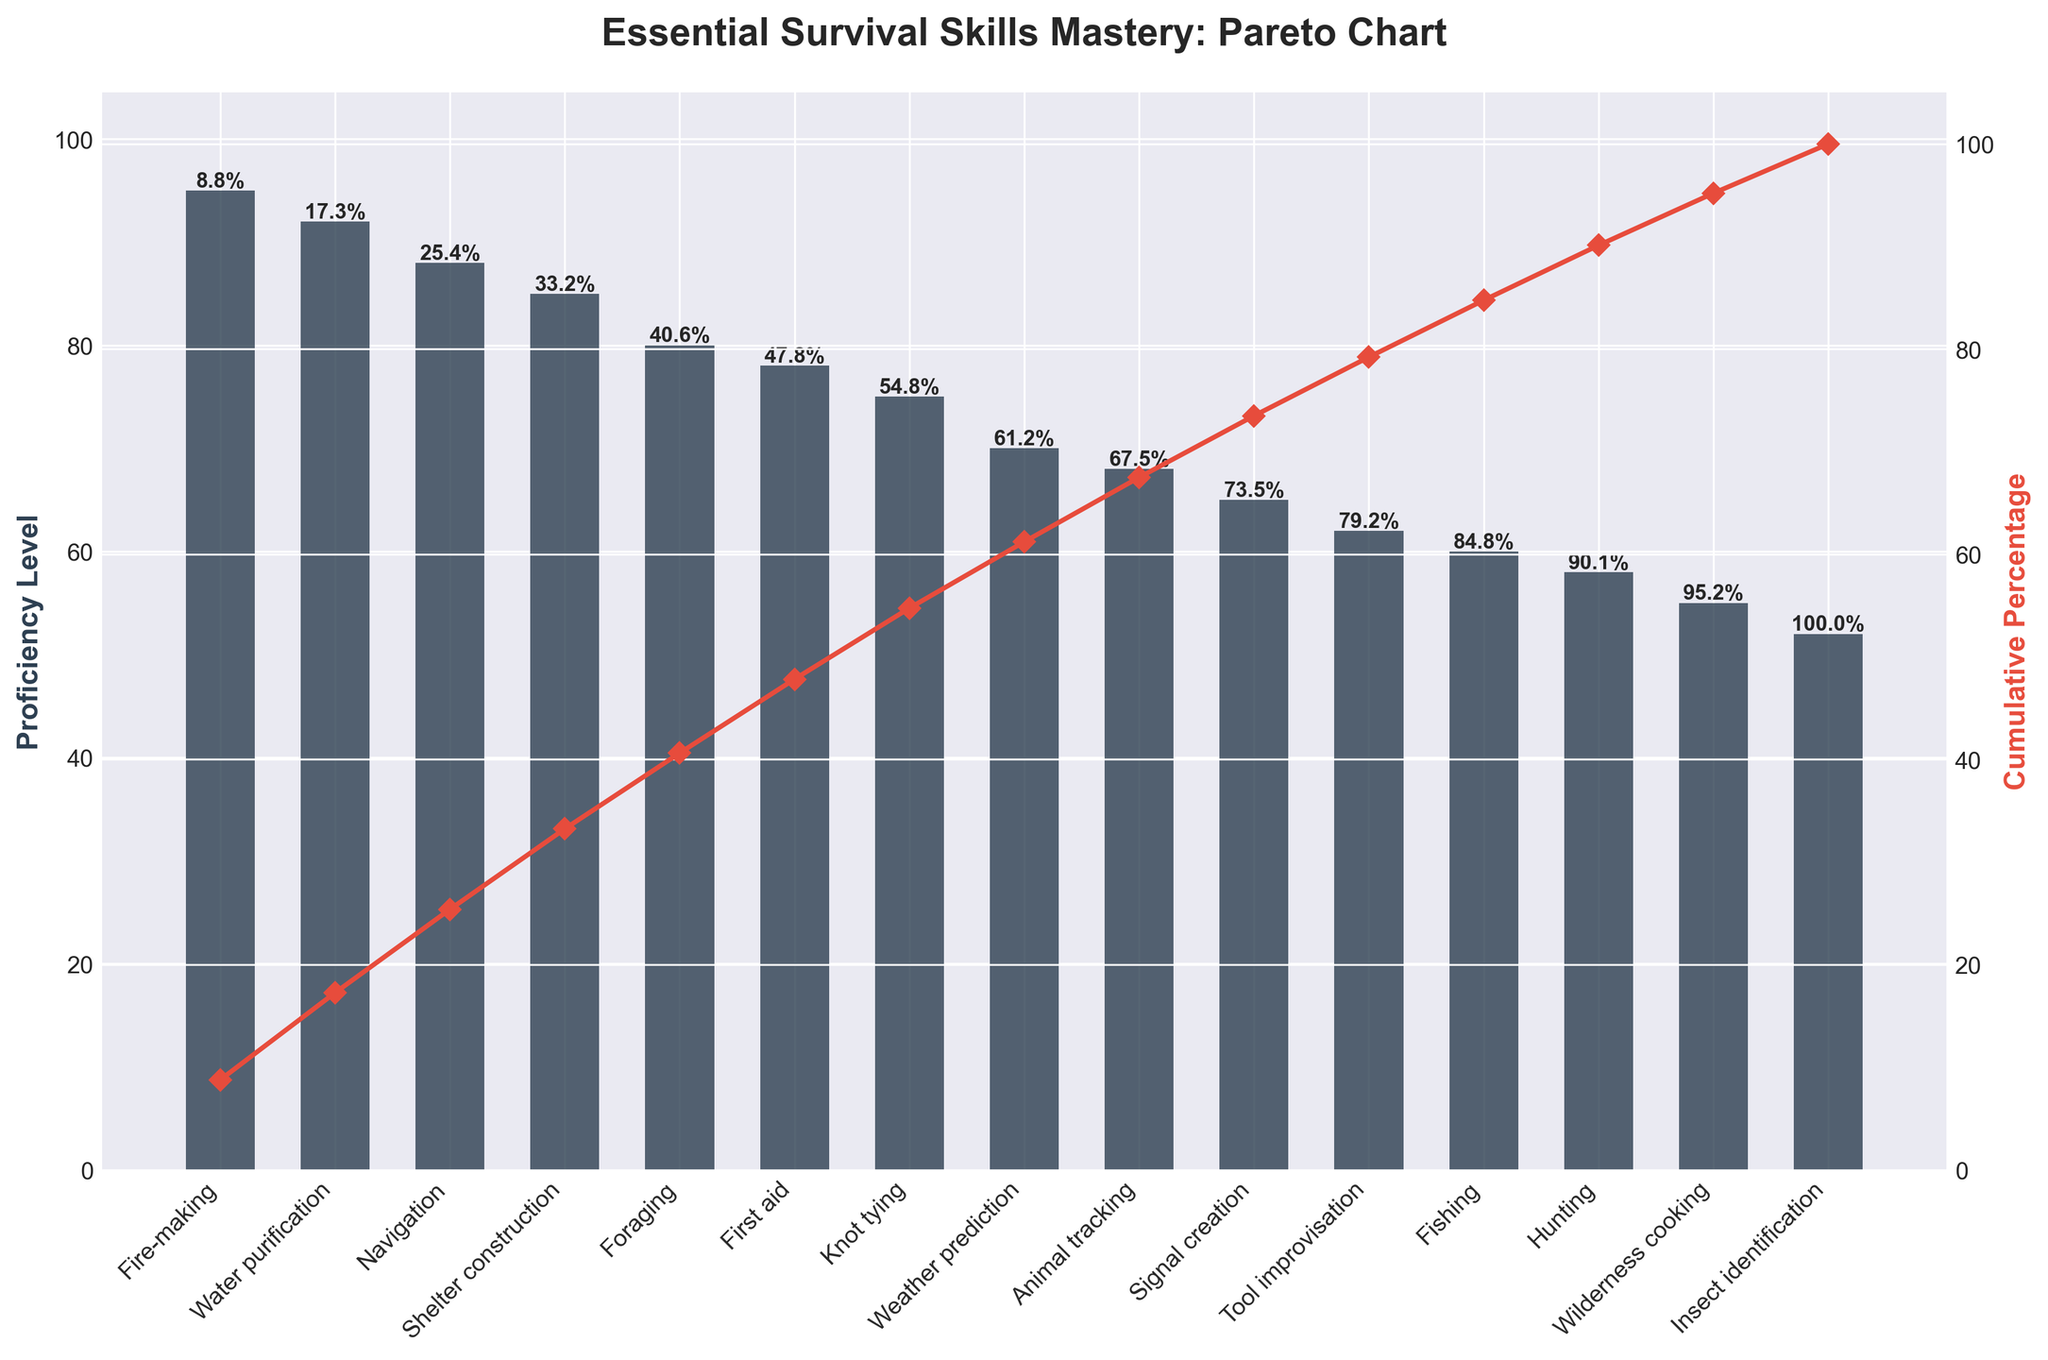What is the highest proficiency level identified in the chart? The highest proficiency level can be found by looking at the tallest bar in the bar chart, which represents the skill with the highest proficiency level.
Answer: Fire-making, 95 What are the proficiency levels for Fire-making and Water purification? Check the heights of the bars corresponding to Fire-making and Water purification. Fire-making is labeled at 95, and Water purification is labeled at 92.
Answer: Fire-making: 95, Water purification: 92 Which skill is indicated to have a cumulative percentage of 50% according to the Pareto line? Look at the cumulative percentage values labeled along the Pareto line. The skill whose cumulative percentage is closest to 50% marks the halfway point.
Answer: Shelter construction What is the proficiency level difference between Knot tying and Signal creation? Knot tying has a proficiency level of 75, and Signal creation has a level of 65. Subtract the two values to find the difference: 75 - 65.
Answer: 10 How many skills have a proficiency level of 70 or above? Count the number of bars that reach at least the 70 mark on the y-axis. There are eight such skills.
Answer: 8 Which skill has the lowest proficiency level, and what is it? Identify the shortest bar in the bar chart, which corresponds to the skill with the lowest proficiency level.
Answer: Insect identification, 52 What percentage of proficiency is covered by the top three skills? The top three skills are Fire-making (95), Water purification (92), and Navigation (88). Add their proficiency levels and divide by the total sum of all proficiency levels, then multiply by 100 for the percentage. Total proficiency points = 95 + 92 + 88 = 275. The sum of all skills' proficiency levels = 1075. Percentage = (275 / 1075) * 100.
Answer: 25.6% How does the proficiency level of Animal tracking compare to Fishing? Compare the heights of the bars for Animal tracking and Fishing. Animal tracking is at 68, and Fishing is at 60.
Answer: Animal tracking is greater What cumulative percentage does the skill First aid contribute according to the Pareto line? Identify the skill First aid on the x-axis and trace upwards to the corresponding label on the Pareto line. First aid's cumulative percentage is around 78%.
Answer: 78% What is the cumulative percentage for the skill Weather prediction? Find the skill Weather prediction on the x-axis and then check the percentage marker on the cumulative percentage line that aligns with this skill.
Answer: 78.7% 